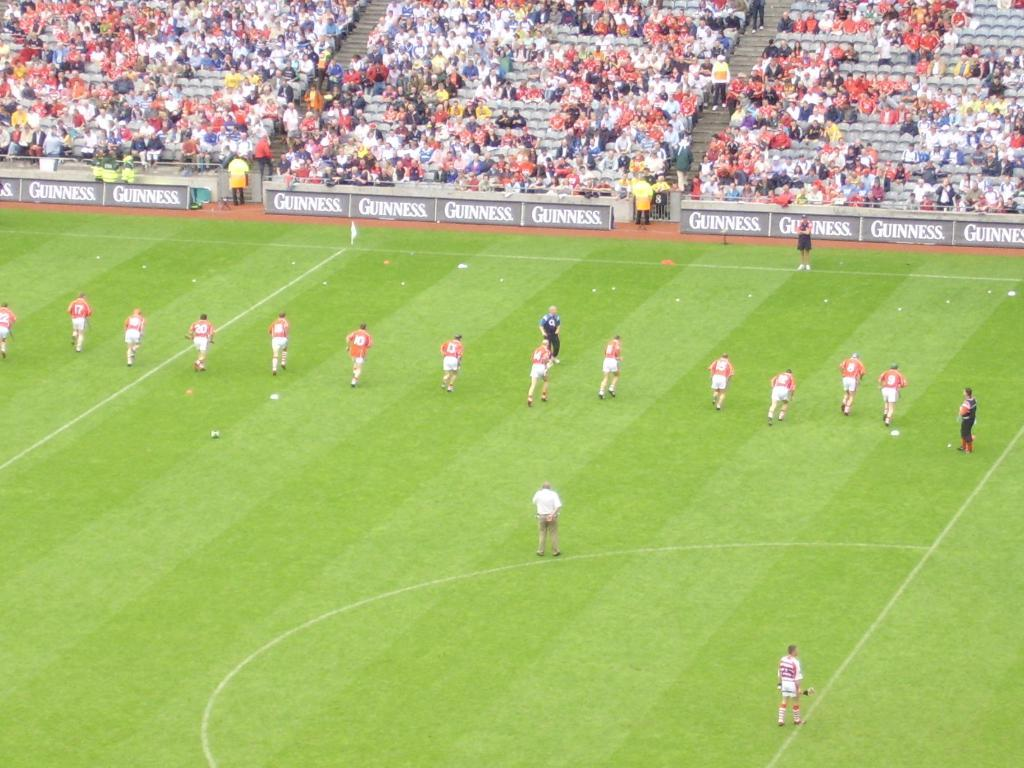<image>
Describe the image concisely. Many Guinness signs line the edges of this large soccer field. 